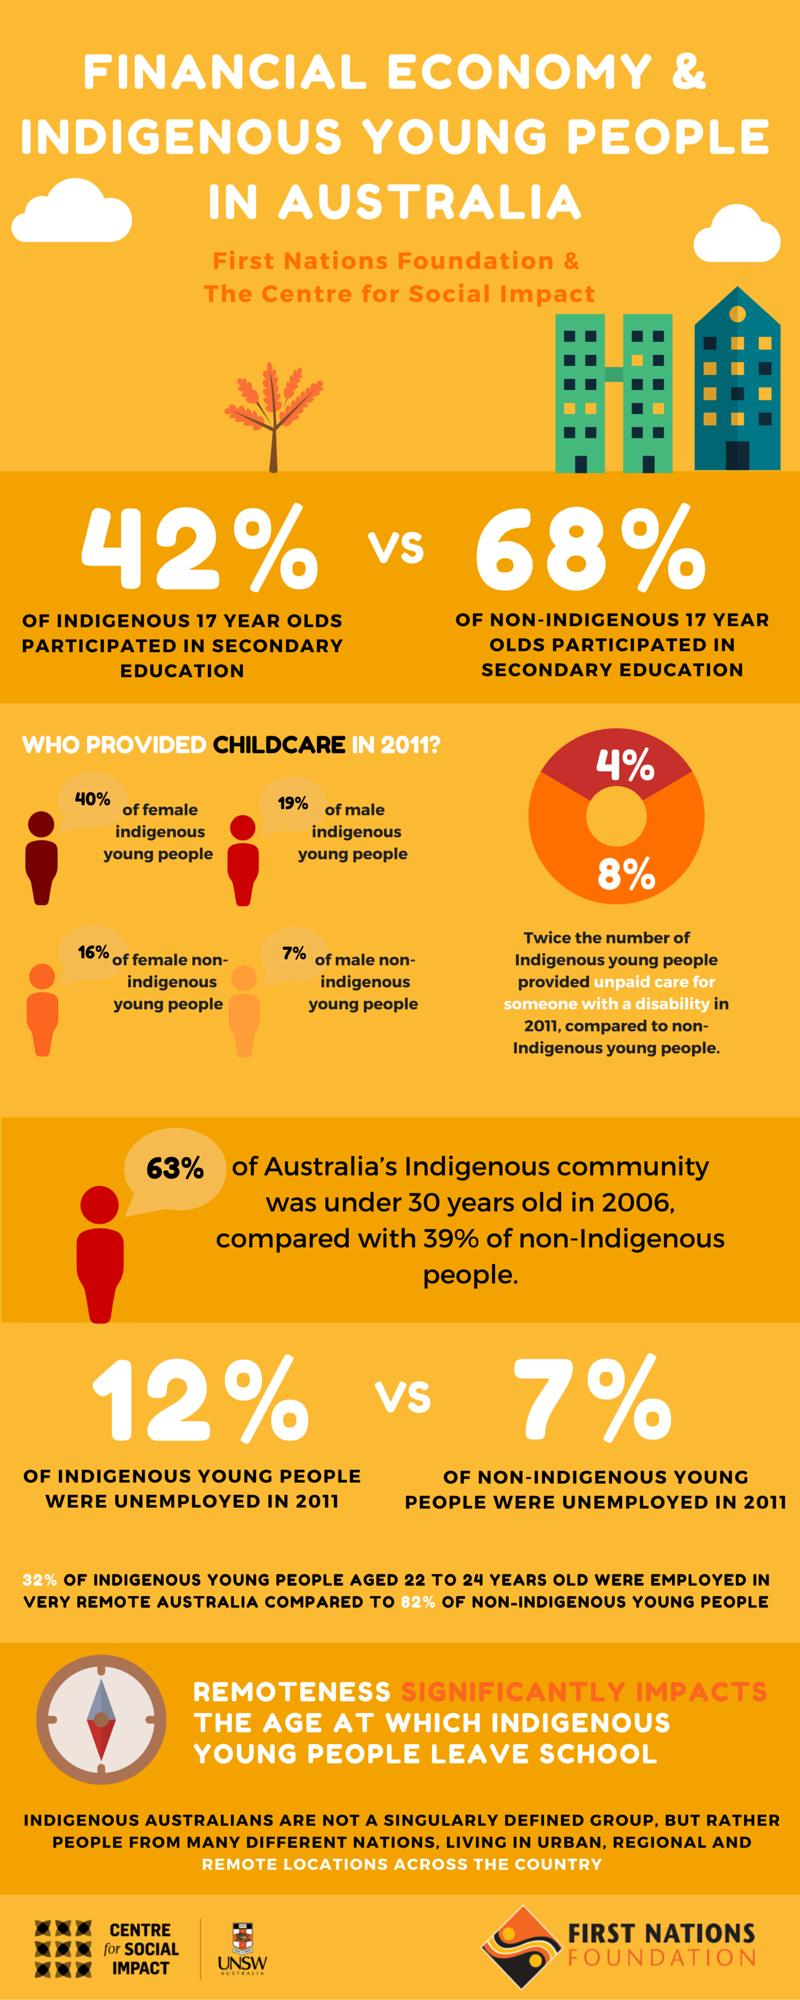Specify some key components in this picture. In 2011, it was found that 60% of female indigenous young people did not provide childcare. In 2011, it was found that 93% of male non-indigenous young people did not provide childcare. In 2011, it was reported that 88% of indigenous young people were employed. In 2011, it was found that 84% of female non-indigenous young people did not provide childcare. In 2011, the percentage of non-indigenous young people employed was 93%. 